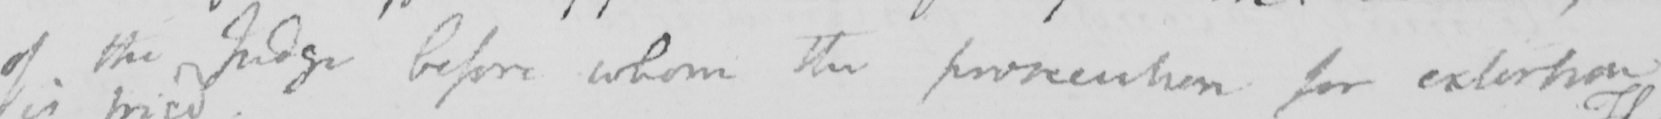What does this handwritten line say? of the Judge before whom the prosecution for extortion 